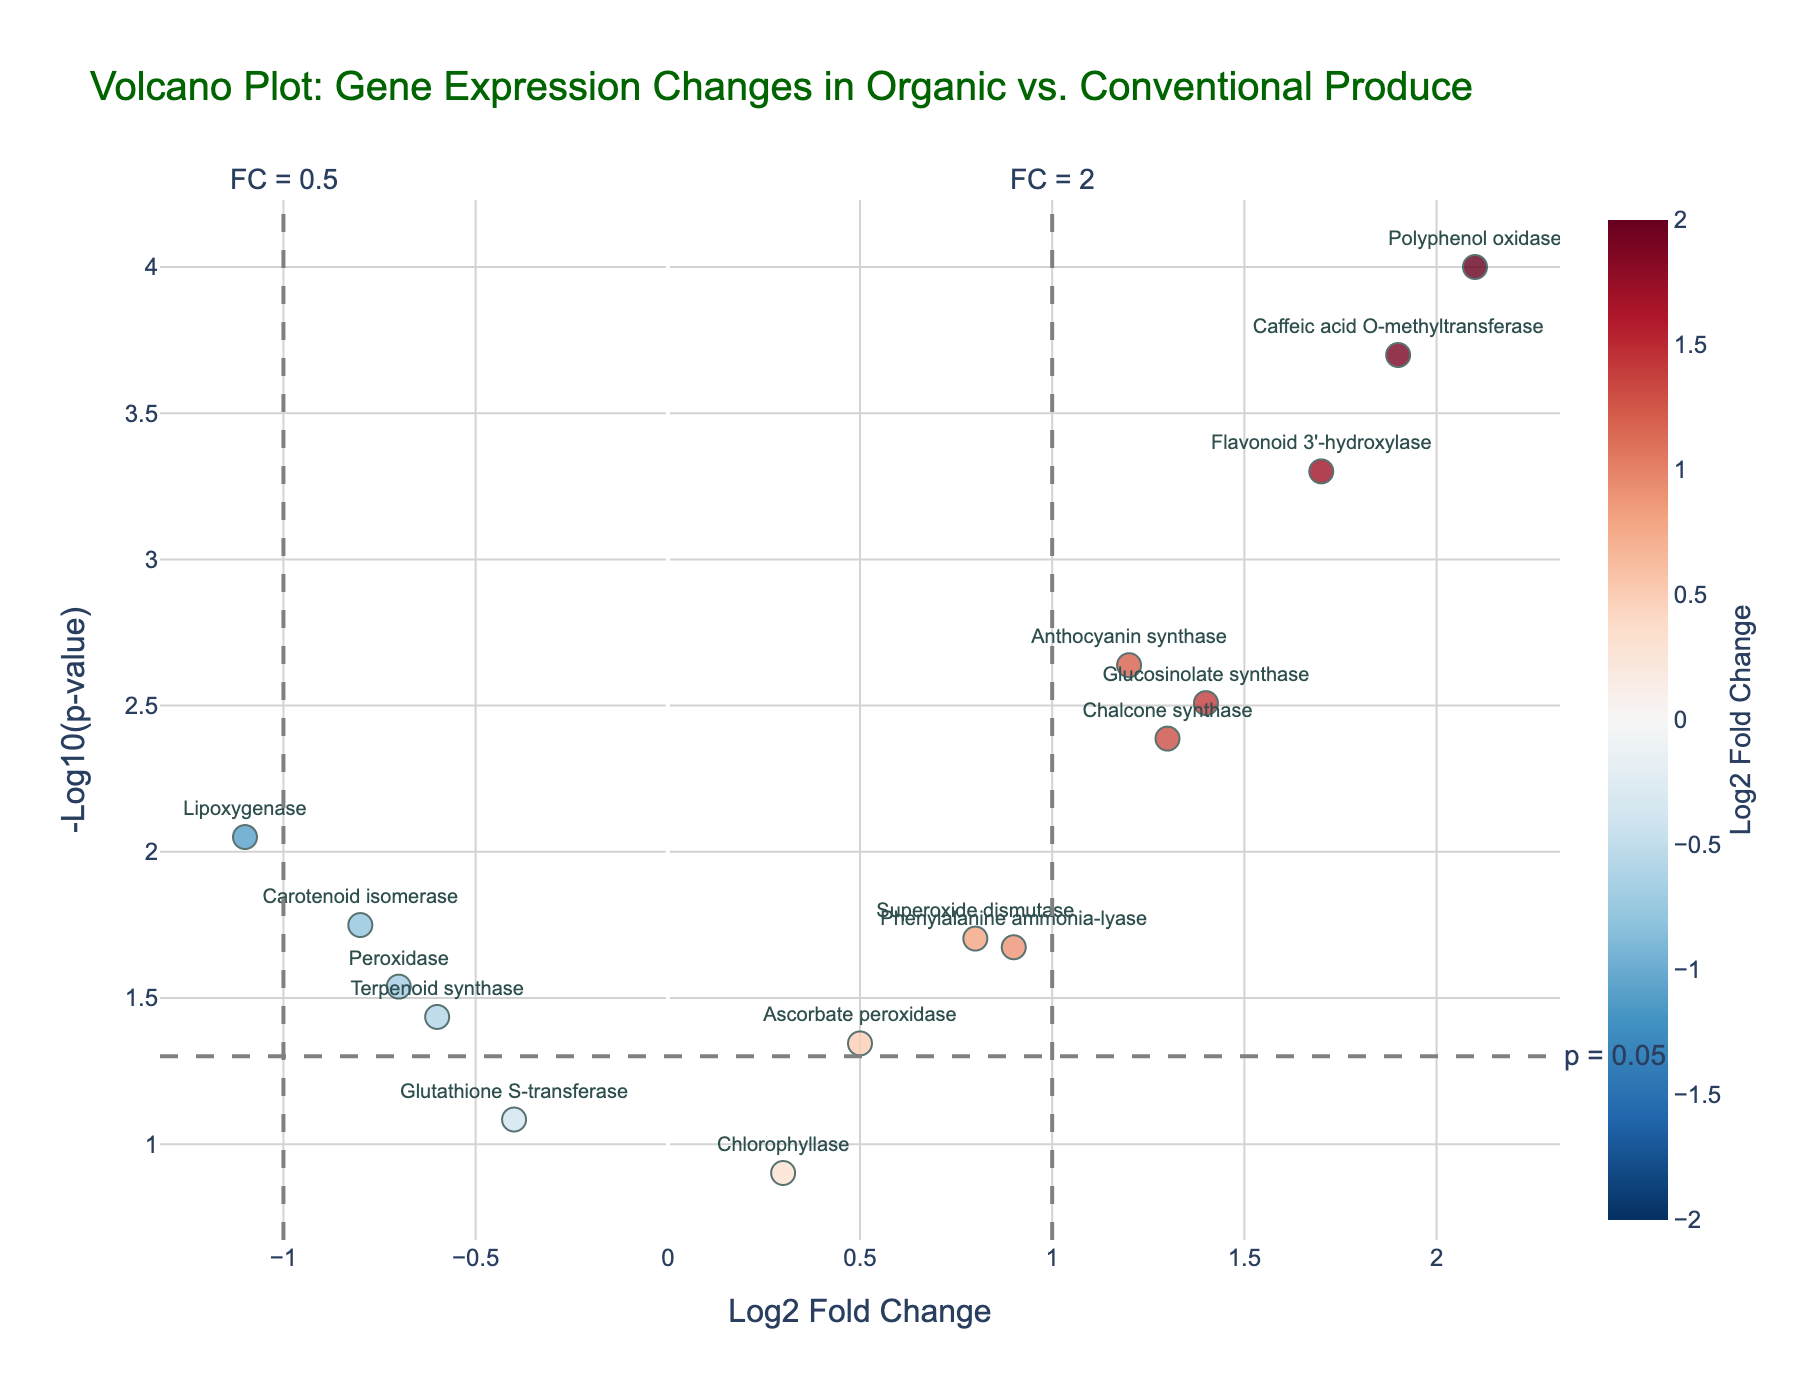How many genes have a log2 fold change greater than 1? By examining the x-axis (Log2 Fold Change), identify the points to the right of 1.
Answer: 7 Which gene has the highest -log10(p-value)? Look for the highest point on the y-axis (-Log10 p-value) and identify the corresponding gene.
Answer: Polyphenol oxidase What is the title of the plot? The title is usually displayed at the top of the plot.
Answer: Volcano Plot: Gene Expression Changes in Organic vs. Conventional Produce Which gene has the lowest log2 fold change? Identify the point furthest to the left on the x-axis (Log2 Fold Change) and determine the corresponding gene.
Answer: Lipoxygenase How many genes are below the p-value threshold of 0.05? Find the number of points above the horizontal dashed line representing the significance threshold.
Answer: 12 What is the approximate log2 fold change of 'Caffeic acid O-methyltransferase'? Locate 'Caffeic acid O-methyltransferase' on the plot and read its value on the x-axis.
Answer: 1.9 Which gene has the smallest -log10(p-value) while still being significant (p < 0.05)? Among the points above the significant threshold line, find the one with the lowest y-axis value.
Answer: Ascorbate peroxidase What range of log2 fold changes is represented by the color scale? Examine the color bar legend to find the range of values.
Answer: -2 to 2 Which gene has a log2 fold change closest to 0.5? Look for the point nearest to 0.5 on the x-axis and identify the corresponding gene.
Answer: Ascorbate peroxidase How many genes show a decrease in expression (negative log2 fold change)? Count the number of points to the left of 0 on the x-axis (log2 fold change).
Answer: 5 